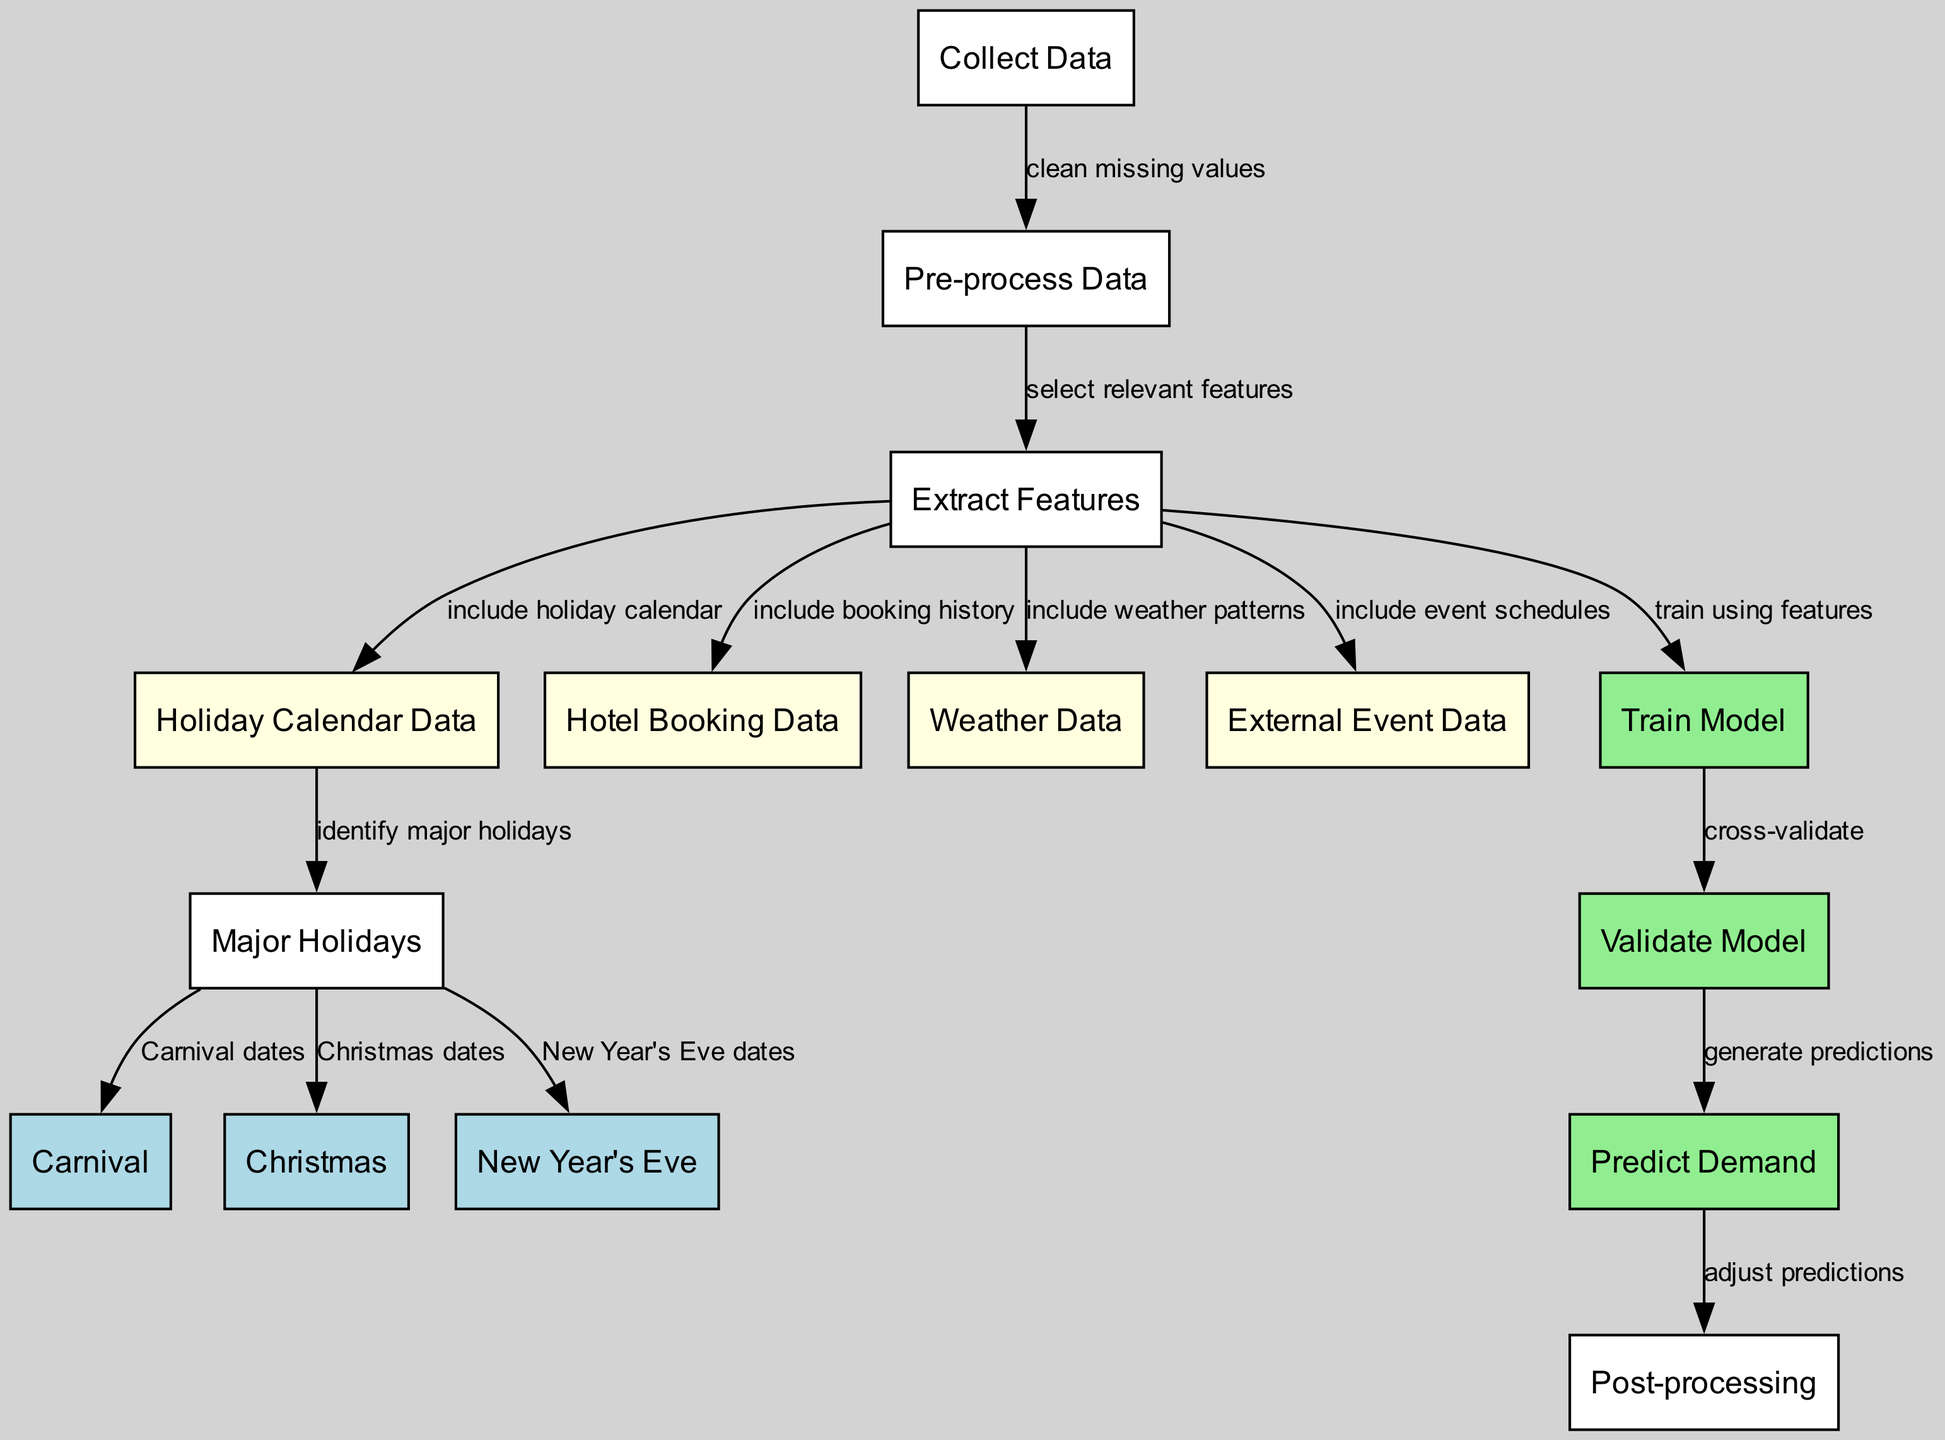What is the first step in the diagram? The diagram begins with the "Collect Data" node, which is the first step in the process of demand forecasting.
Answer: Collect Data How many major holidays are identified in the diagram? The diagram identifies three major holidays: Carnival, Christmas, and New Year's Eve, as noted in the edges leading from the "Major Holidays" node.
Answer: Three What type of data is included in the feature extraction process? The feature extraction process includes holiday calendar data, hotel booking data, weather data, and external event data, as indicated by the edges leading from the "Extract Features" node.
Answer: Holiday calendar data, hotel booking data, weather data, external event data What action follows the validation of the model? After validating the model, the next action is to "Predict Demand," which derives from the "Validate Model" node, as indicated by the edge connecting them.
Answer: Predict Demand Which node is responsible for adjusting predictions? The "Post-processing" node is responsible for adjusting predictions, as shown by the edge leading from the "Predict Demand" node to the "Post-processing" node.
Answer: Post-processing What do the edges from the "Extract Features" node point to? The edges from the "Extract Features" node point to four data sources: "Holiday Calendar Data," "Hotel Booking Data," "Weather Data," and "External Event Data," showing the flow of feature extraction.
Answer: Holiday Calendar Data, Hotel Booking Data, Weather Data, External Event Data How do we ensure the model is accurate according to the diagram? To ensure model accuracy, the process includes cross-validation, denoted by the edge from the "Train Model" node to the "Validate Model" node, indicating this important step.
Answer: Cross-validate What is the purpose of the "Train Model" node? The purpose of the "Train Model" node is to create a predictive model using the features selected in the previous steps, as highlighted by the edge connecting "Extract Features" and "Train Model."
Answer: Train a predictive model What connects the "Holiday Calendar Data" to the major holidays? The node "Holiday Calendar Data" connects to "Major Holidays," indicating the identification of major holidays, which is detailed by the edges leading to Carnival, Christmas, and New Year's Eve.
Answer: Identify major holidays 